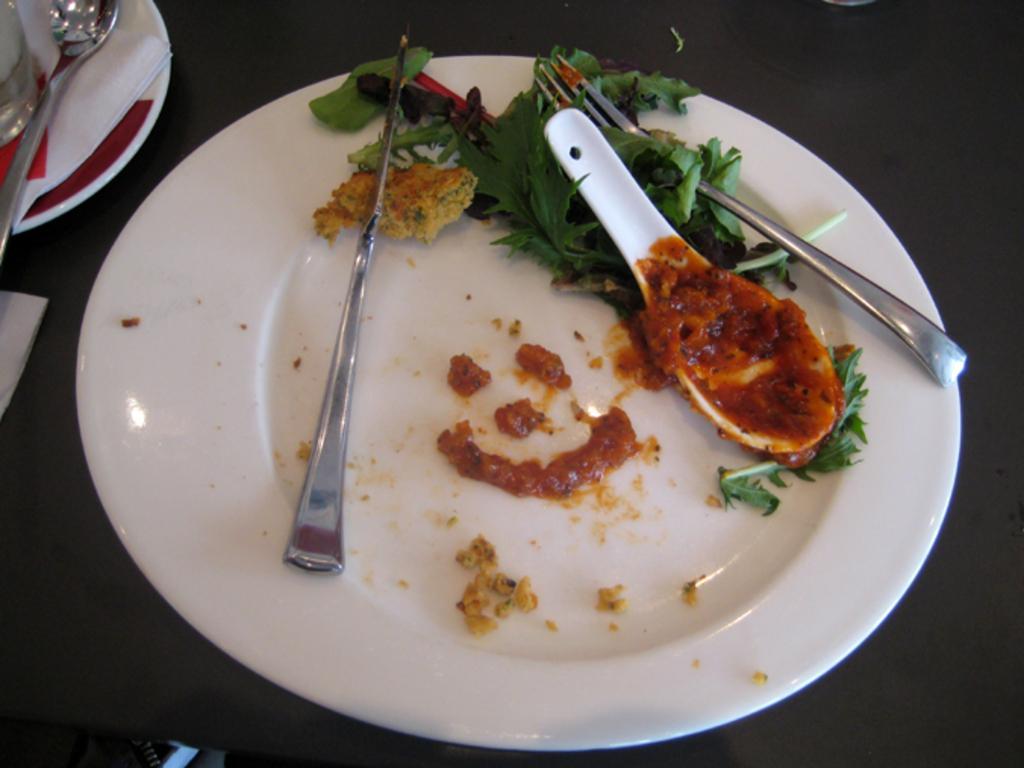Could you give a brief overview of what you see in this image? In this picture we can see a plate and on plate we have fork, spoon, leaves, knife and aside to this place we have tissue papers, spoon on plate. 